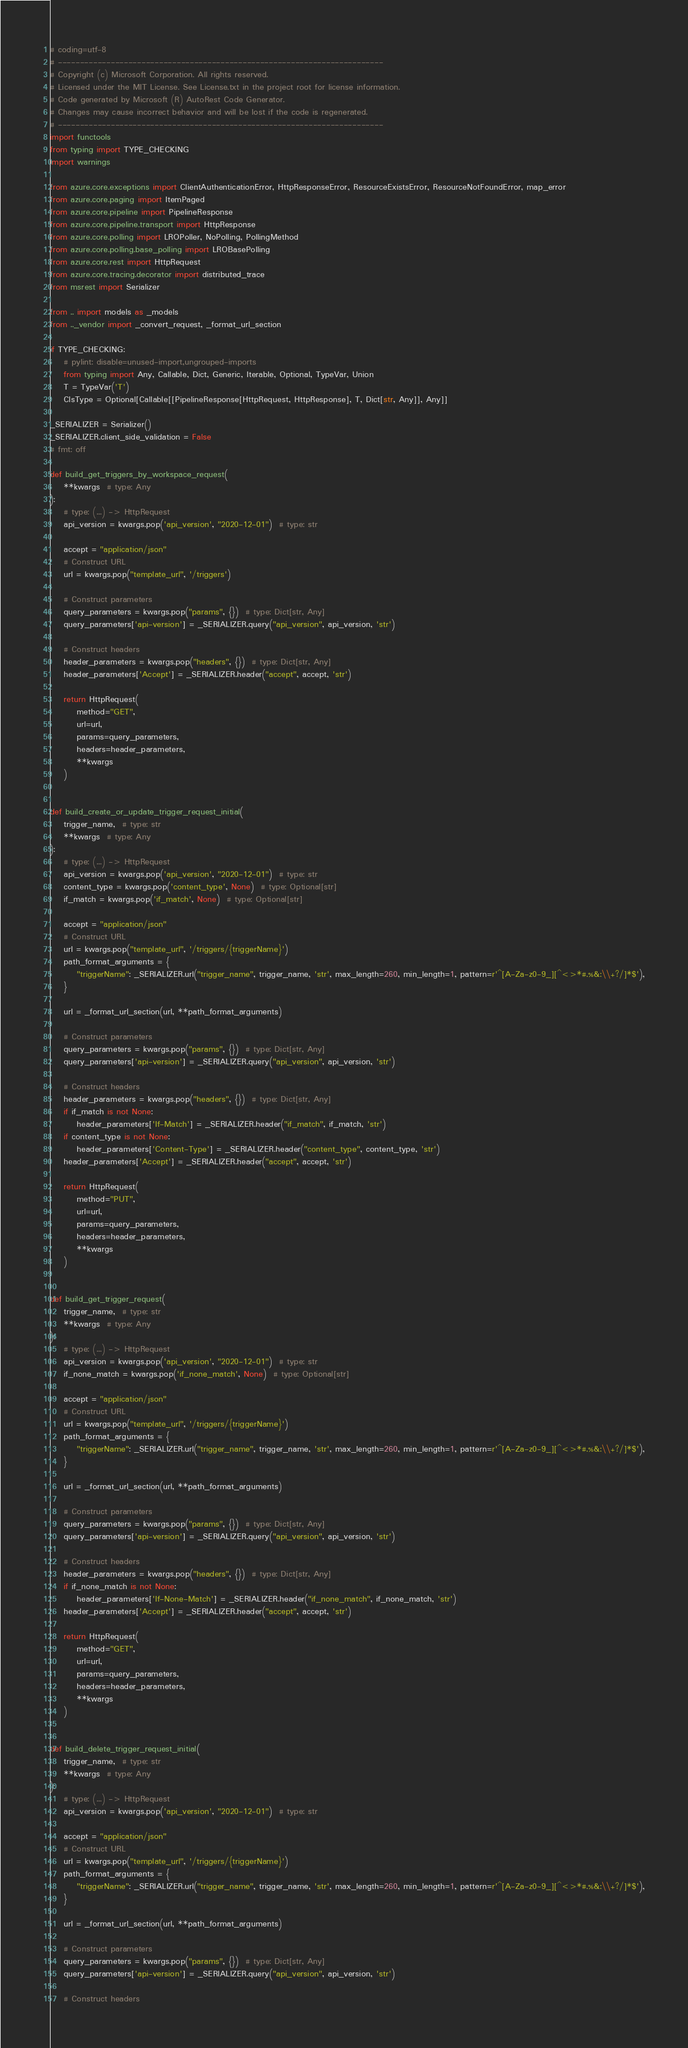<code> <loc_0><loc_0><loc_500><loc_500><_Python_># coding=utf-8
# --------------------------------------------------------------------------
# Copyright (c) Microsoft Corporation. All rights reserved.
# Licensed under the MIT License. See License.txt in the project root for license information.
# Code generated by Microsoft (R) AutoRest Code Generator.
# Changes may cause incorrect behavior and will be lost if the code is regenerated.
# --------------------------------------------------------------------------
import functools
from typing import TYPE_CHECKING
import warnings

from azure.core.exceptions import ClientAuthenticationError, HttpResponseError, ResourceExistsError, ResourceNotFoundError, map_error
from azure.core.paging import ItemPaged
from azure.core.pipeline import PipelineResponse
from azure.core.pipeline.transport import HttpResponse
from azure.core.polling import LROPoller, NoPolling, PollingMethod
from azure.core.polling.base_polling import LROBasePolling
from azure.core.rest import HttpRequest
from azure.core.tracing.decorator import distributed_trace
from msrest import Serializer

from .. import models as _models
from .._vendor import _convert_request, _format_url_section

if TYPE_CHECKING:
    # pylint: disable=unused-import,ungrouped-imports
    from typing import Any, Callable, Dict, Generic, Iterable, Optional, TypeVar, Union
    T = TypeVar('T')
    ClsType = Optional[Callable[[PipelineResponse[HttpRequest, HttpResponse], T, Dict[str, Any]], Any]]

_SERIALIZER = Serializer()
_SERIALIZER.client_side_validation = False
# fmt: off

def build_get_triggers_by_workspace_request(
    **kwargs  # type: Any
):
    # type: (...) -> HttpRequest
    api_version = kwargs.pop('api_version', "2020-12-01")  # type: str

    accept = "application/json"
    # Construct URL
    url = kwargs.pop("template_url", '/triggers')

    # Construct parameters
    query_parameters = kwargs.pop("params", {})  # type: Dict[str, Any]
    query_parameters['api-version'] = _SERIALIZER.query("api_version", api_version, 'str')

    # Construct headers
    header_parameters = kwargs.pop("headers", {})  # type: Dict[str, Any]
    header_parameters['Accept'] = _SERIALIZER.header("accept", accept, 'str')

    return HttpRequest(
        method="GET",
        url=url,
        params=query_parameters,
        headers=header_parameters,
        **kwargs
    )


def build_create_or_update_trigger_request_initial(
    trigger_name,  # type: str
    **kwargs  # type: Any
):
    # type: (...) -> HttpRequest
    api_version = kwargs.pop('api_version', "2020-12-01")  # type: str
    content_type = kwargs.pop('content_type', None)  # type: Optional[str]
    if_match = kwargs.pop('if_match', None)  # type: Optional[str]

    accept = "application/json"
    # Construct URL
    url = kwargs.pop("template_url", '/triggers/{triggerName}')
    path_format_arguments = {
        "triggerName": _SERIALIZER.url("trigger_name", trigger_name, 'str', max_length=260, min_length=1, pattern=r'^[A-Za-z0-9_][^<>*#.%&:\\+?/]*$'),
    }

    url = _format_url_section(url, **path_format_arguments)

    # Construct parameters
    query_parameters = kwargs.pop("params", {})  # type: Dict[str, Any]
    query_parameters['api-version'] = _SERIALIZER.query("api_version", api_version, 'str')

    # Construct headers
    header_parameters = kwargs.pop("headers", {})  # type: Dict[str, Any]
    if if_match is not None:
        header_parameters['If-Match'] = _SERIALIZER.header("if_match", if_match, 'str')
    if content_type is not None:
        header_parameters['Content-Type'] = _SERIALIZER.header("content_type", content_type, 'str')
    header_parameters['Accept'] = _SERIALIZER.header("accept", accept, 'str')

    return HttpRequest(
        method="PUT",
        url=url,
        params=query_parameters,
        headers=header_parameters,
        **kwargs
    )


def build_get_trigger_request(
    trigger_name,  # type: str
    **kwargs  # type: Any
):
    # type: (...) -> HttpRequest
    api_version = kwargs.pop('api_version', "2020-12-01")  # type: str
    if_none_match = kwargs.pop('if_none_match', None)  # type: Optional[str]

    accept = "application/json"
    # Construct URL
    url = kwargs.pop("template_url", '/triggers/{triggerName}')
    path_format_arguments = {
        "triggerName": _SERIALIZER.url("trigger_name", trigger_name, 'str', max_length=260, min_length=1, pattern=r'^[A-Za-z0-9_][^<>*#.%&:\\+?/]*$'),
    }

    url = _format_url_section(url, **path_format_arguments)

    # Construct parameters
    query_parameters = kwargs.pop("params", {})  # type: Dict[str, Any]
    query_parameters['api-version'] = _SERIALIZER.query("api_version", api_version, 'str')

    # Construct headers
    header_parameters = kwargs.pop("headers", {})  # type: Dict[str, Any]
    if if_none_match is not None:
        header_parameters['If-None-Match'] = _SERIALIZER.header("if_none_match", if_none_match, 'str')
    header_parameters['Accept'] = _SERIALIZER.header("accept", accept, 'str')

    return HttpRequest(
        method="GET",
        url=url,
        params=query_parameters,
        headers=header_parameters,
        **kwargs
    )


def build_delete_trigger_request_initial(
    trigger_name,  # type: str
    **kwargs  # type: Any
):
    # type: (...) -> HttpRequest
    api_version = kwargs.pop('api_version', "2020-12-01")  # type: str

    accept = "application/json"
    # Construct URL
    url = kwargs.pop("template_url", '/triggers/{triggerName}')
    path_format_arguments = {
        "triggerName": _SERIALIZER.url("trigger_name", trigger_name, 'str', max_length=260, min_length=1, pattern=r'^[A-Za-z0-9_][^<>*#.%&:\\+?/]*$'),
    }

    url = _format_url_section(url, **path_format_arguments)

    # Construct parameters
    query_parameters = kwargs.pop("params", {})  # type: Dict[str, Any]
    query_parameters['api-version'] = _SERIALIZER.query("api_version", api_version, 'str')

    # Construct headers</code> 